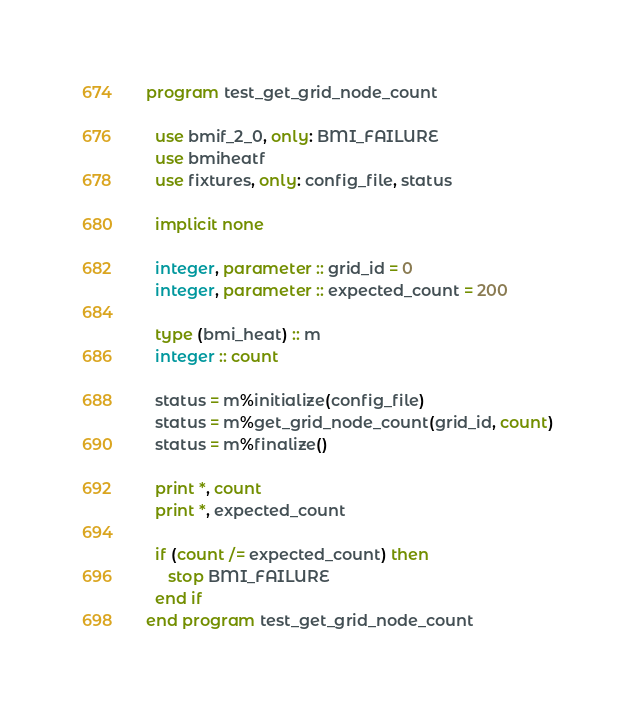<code> <loc_0><loc_0><loc_500><loc_500><_FORTRAN_>program test_get_grid_node_count

  use bmif_2_0, only: BMI_FAILURE
  use bmiheatf
  use fixtures, only: config_file, status

  implicit none

  integer, parameter :: grid_id = 0
  integer, parameter :: expected_count = 200

  type (bmi_heat) :: m
  integer :: count

  status = m%initialize(config_file)
  status = m%get_grid_node_count(grid_id, count)
  status = m%finalize()

  print *, count
  print *, expected_count

  if (count /= expected_count) then
     stop BMI_FAILURE
  end if
end program test_get_grid_node_count
</code> 